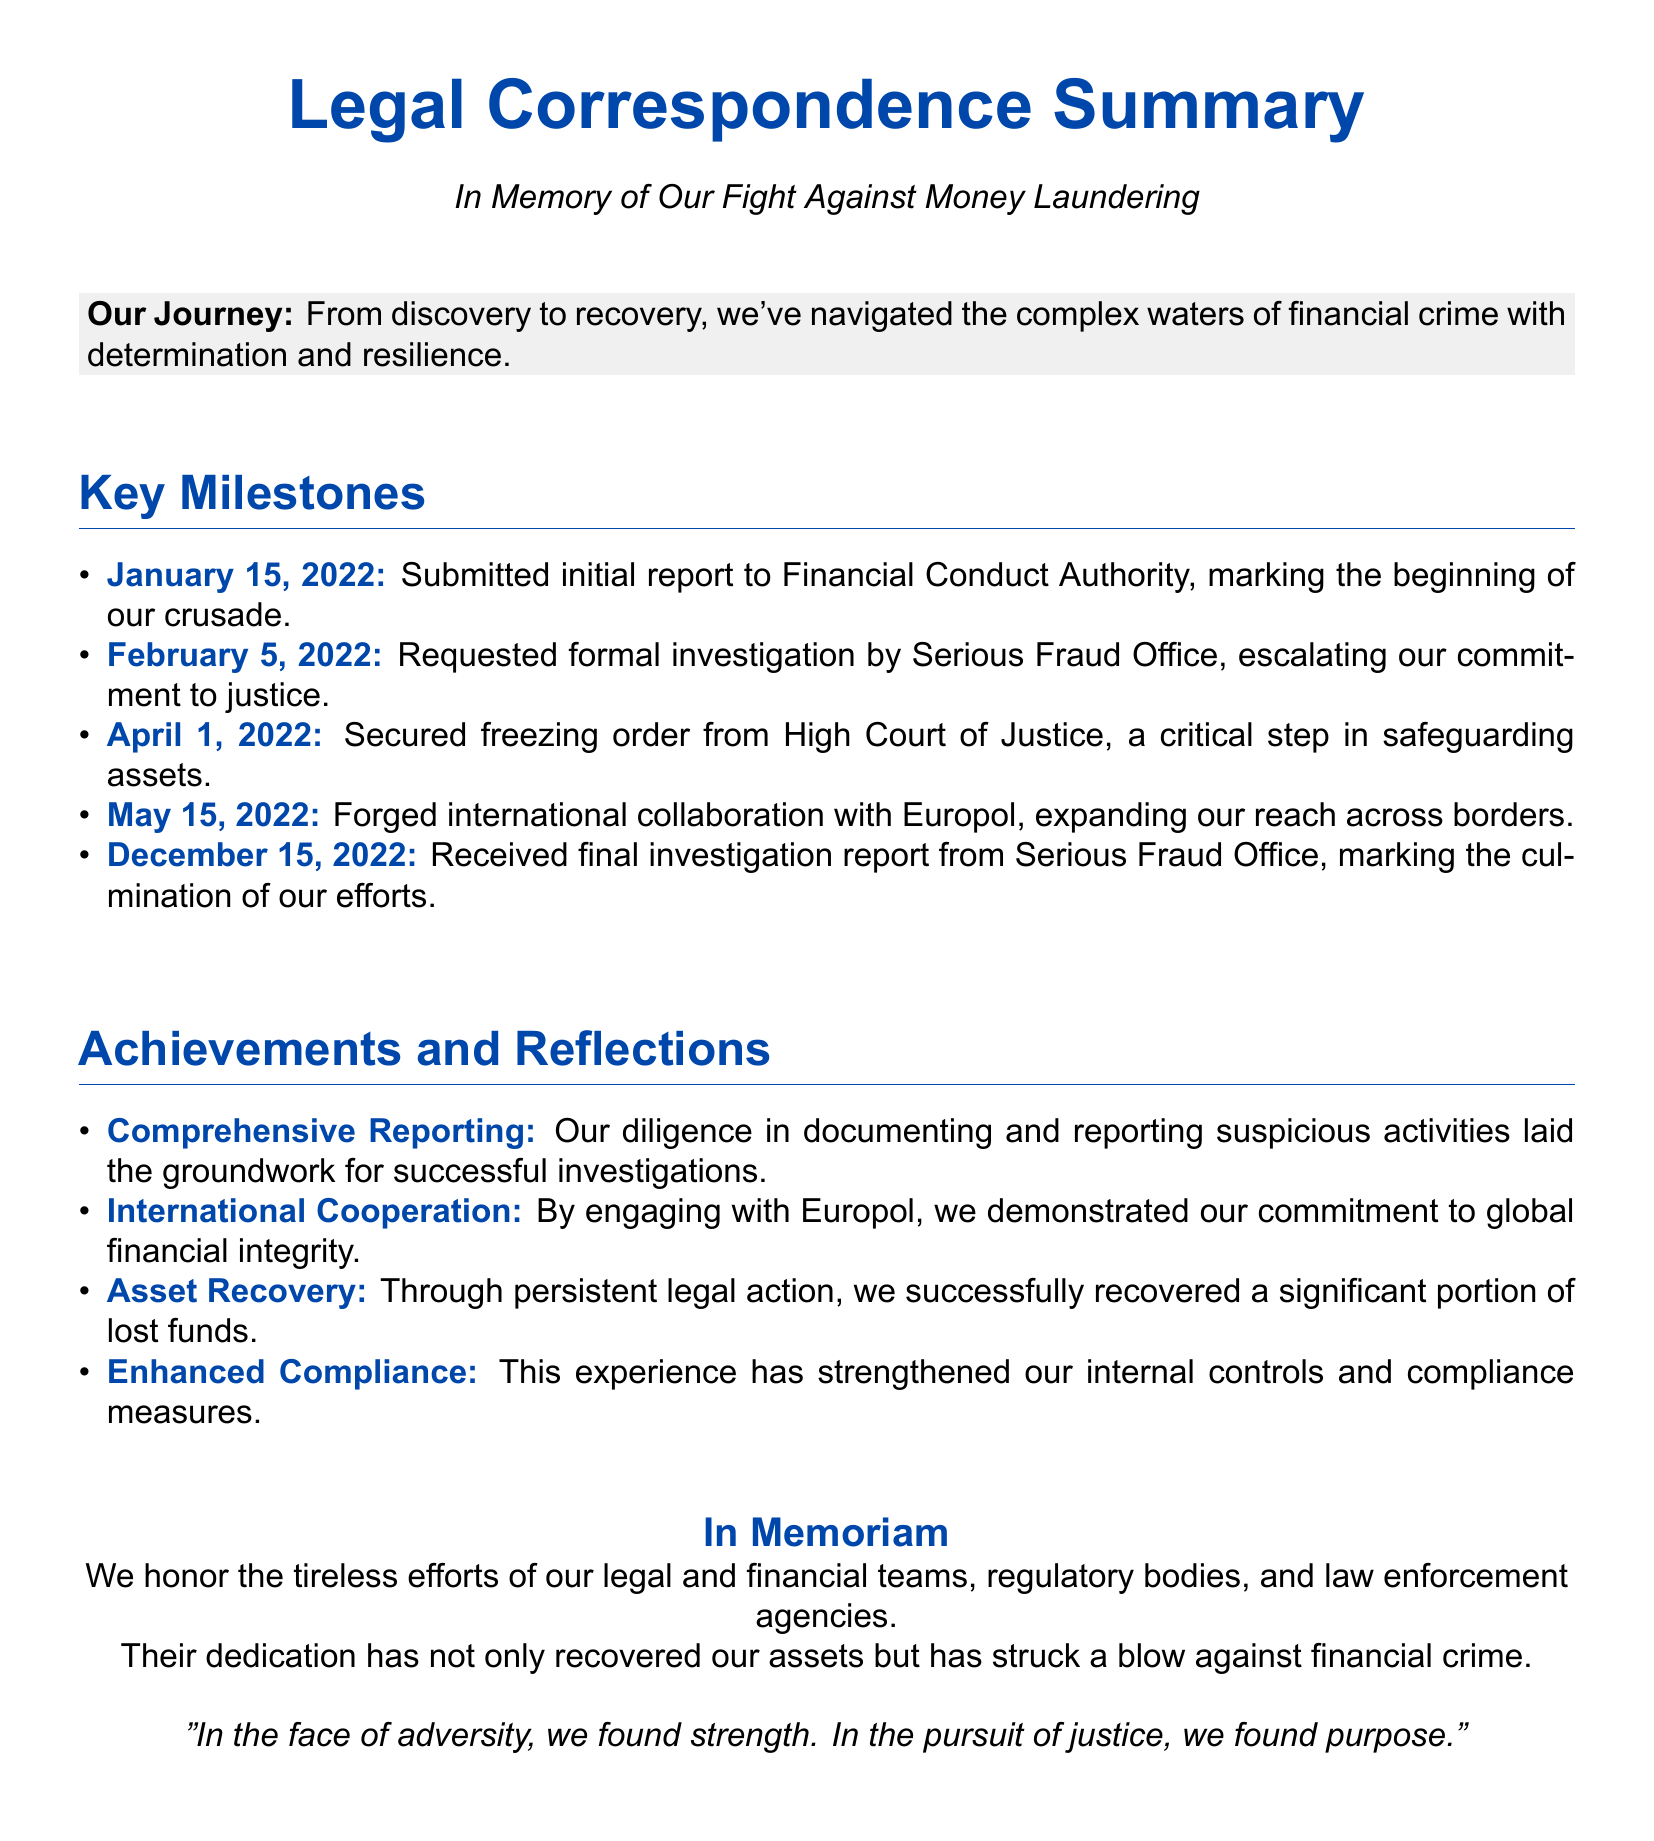What date was the initial report submitted? The date for the submission of the initial report to the Financial Conduct Authority is clearly stated in the document.
Answer: January 15, 2022 What agency was the formal investigation requested from? The agency mentioned in the document for the formal investigation request is specified within the context.
Answer: Serious Fraud Office Which court secured the freezing order? The specific court that secured the freezing order is outlined in the document.
Answer: High Court of Justice What was forged with Europol in May 2022? The collaborative effort mentioned in the document refers to a specific type of agreement.
Answer: International collaboration How many key milestones are listed? The total number of key milestones is indicated by counting the items in the section.
Answer: Five What percentage of lost funds was recovered? The document states that a significant portion was recovered, but does not specify a percentage.
Answer: Significant portion Which teams are honored in the "In Memoriam" section? The document highlights the specific groups responsible for the efforts against money laundering.
Answer: Legal and financial teams What is stated about enhanced compliance? The document reflects on how the experience improved certain measures within the corporation.
Answer: Strengthened internal controls 